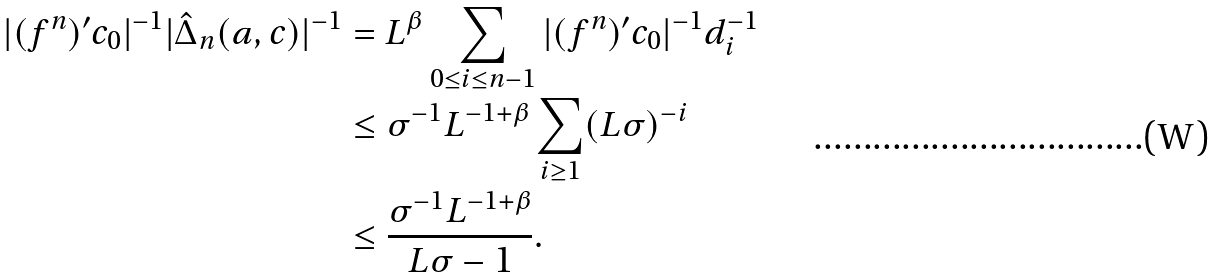Convert formula to latex. <formula><loc_0><loc_0><loc_500><loc_500>| ( f ^ { n } ) ^ { \prime } c _ { 0 } | ^ { - 1 } | \hat { \Delta } _ { n } ( a , c ) | ^ { - 1 } & = L ^ { \beta } \sum _ { 0 \leq i \leq n - 1 } | ( f ^ { n } ) ^ { \prime } c _ { 0 } | ^ { - 1 } d _ { i } ^ { - 1 } \\ & \leq \sigma ^ { - 1 } L ^ { - 1 + \beta } \sum _ { i \geq 1 } ( L \sigma ) ^ { - i } \\ & \leq \frac { \sigma ^ { - 1 } L ^ { - 1 + \beta } } { L \sigma - 1 } .</formula> 